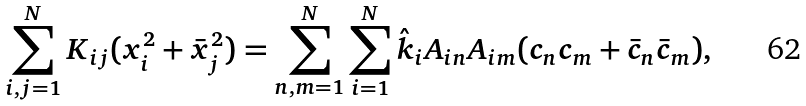Convert formula to latex. <formula><loc_0><loc_0><loc_500><loc_500>\sum _ { i , j = 1 } ^ { N } K _ { i j } ( x _ { i } ^ { 2 } + \bar { x } _ { j } ^ { 2 } ) = \sum _ { n , m = 1 } ^ { N } \sum _ { i = 1 } ^ { N } \hat { k } _ { i } A _ { i n } A _ { i m } ( c _ { n } c _ { m } + \bar { c } _ { n } \bar { c } _ { m } ) ,</formula> 